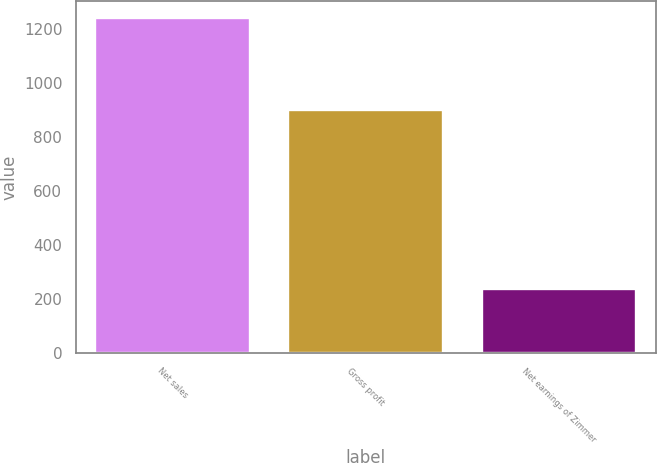<chart> <loc_0><loc_0><loc_500><loc_500><bar_chart><fcel>Net sales<fcel>Gross profit<fcel>Net earnings of Zimmer<nl><fcel>1240.7<fcel>899.9<fcel>235.9<nl></chart> 